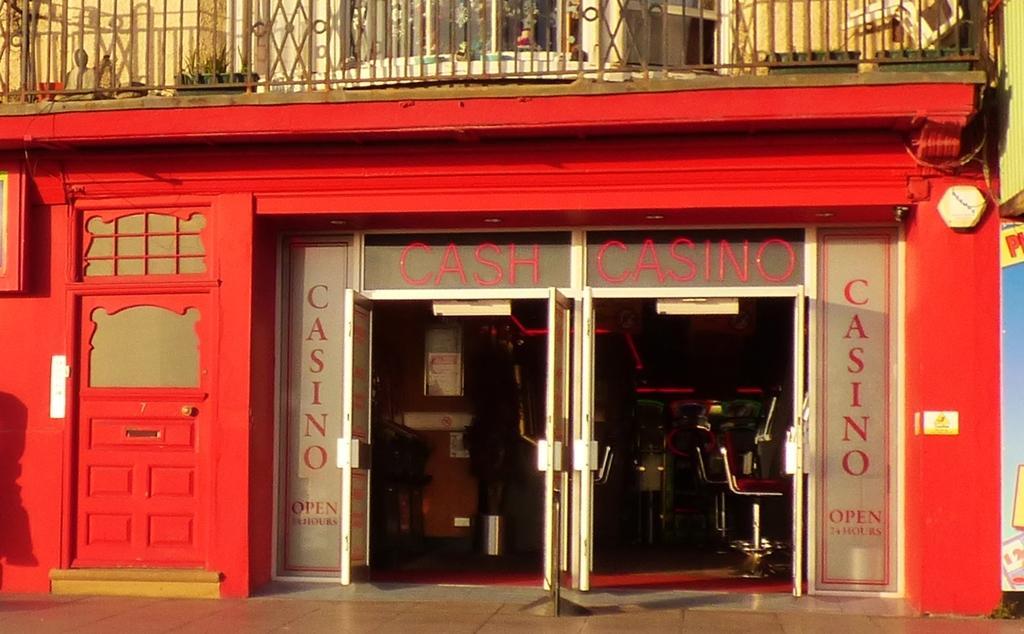Can you describe this image briefly? In this picture we can see store, doors, grille, chairs, boards, hoarding and things. Behind the grill there is a plant. 